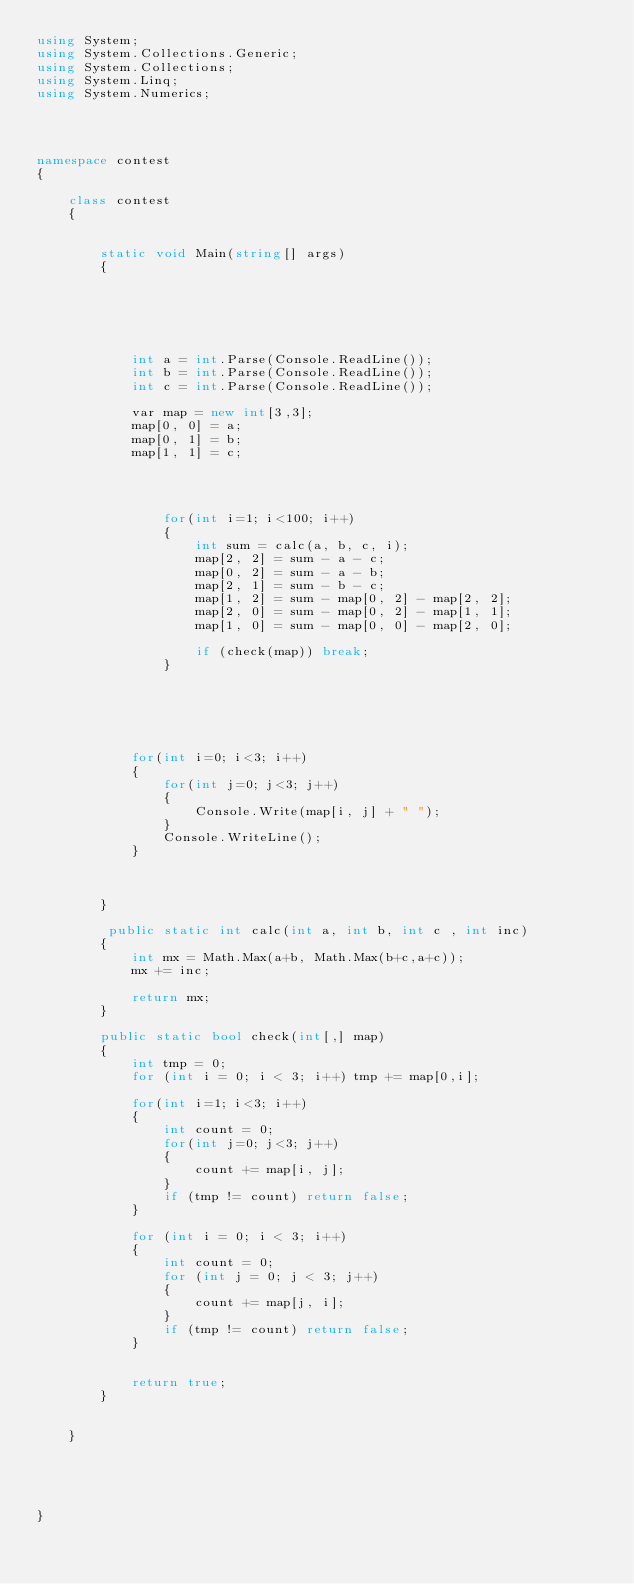Convert code to text. <code><loc_0><loc_0><loc_500><loc_500><_C#_>using System;
using System.Collections.Generic;
using System.Collections;
using System.Linq;
using System.Numerics;




namespace contest
{

    class contest
    {


        static void Main(string[] args)
        {


      


           
            int a = int.Parse(Console.ReadLine());
            int b = int.Parse(Console.ReadLine());
            int c = int.Parse(Console.ReadLine());

            var map = new int[3,3];
            map[0, 0] = a;
            map[0, 1] = b;
            map[1, 1] = c;

            
            
                
                for(int i=1; i<100; i++)
                {
                    int sum = calc(a, b, c, i);
                    map[2, 2] = sum - a - c;
                    map[0, 2] = sum - a - b;
                    map[2, 1] = sum - b - c;
                    map[1, 2] = sum - map[0, 2] - map[2, 2];
                    map[2, 0] = sum - map[0, 2] - map[1, 1];
                    map[1, 0] = sum - map[0, 0] - map[2, 0];

                    if (check(map)) break;
                }

                
            



            for(int i=0; i<3; i++)
            {
                for(int j=0; j<3; j++)
                {
                    Console.Write(map[i, j] + " ");
                }
                Console.WriteLine();
            }



        }

		 public static int calc(int a, int b, int c , int inc)
        {
            int mx = Math.Max(a+b, Math.Max(b+c,a+c));
            mx += inc;

            return mx;
        }

        public static bool check(int[,] map)
        {
            int tmp = 0;
            for (int i = 0; i < 3; i++) tmp += map[0,i];

            for(int i=1; i<3; i++)
            {
                int count = 0;
                for(int j=0; j<3; j++)
                {
                    count += map[i, j];
                }
                if (tmp != count) return false;
            }

            for (int i = 0; i < 3; i++)
            {
                int count = 0;
                for (int j = 0; j < 3; j++)
                {
                    count += map[j, i];
                }
                if (tmp != count) return false;
            }


            return true;
        }
        

    }


   

    
}
</code> 